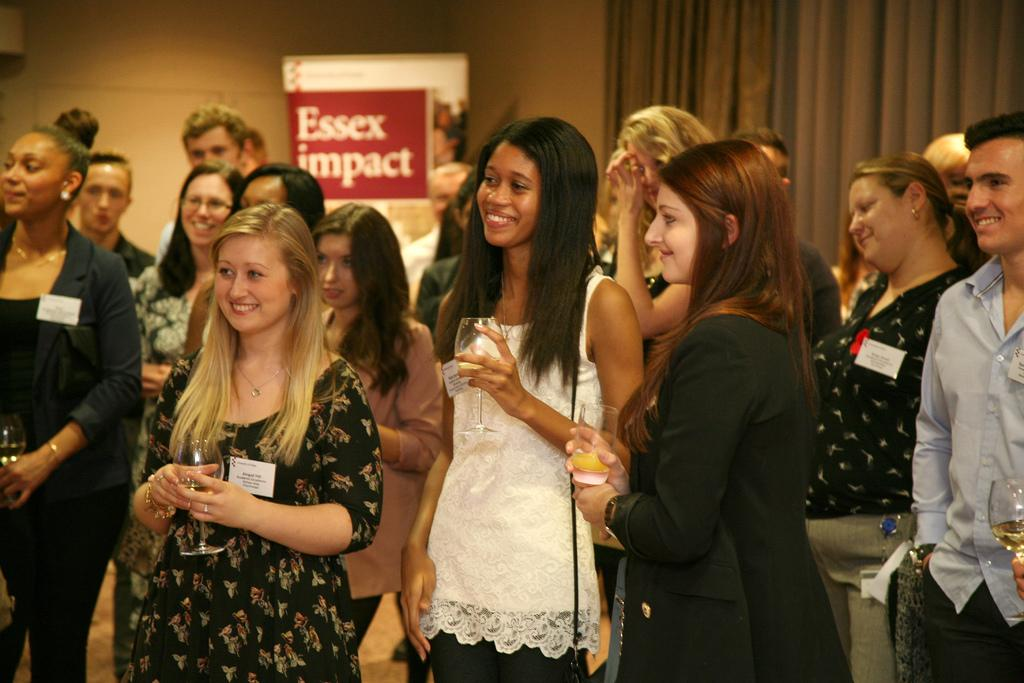How many people are in the image? There are people in the image, but the exact number is not specified. What are some people holding in the image? Some people are holding glasses in the image. What is the general mood or expression of the people in the image? The people in the image are smiling. What can be seen in the background of the image? In the background of the image, there is a curtain, a wall, and a board. Can you tell me how many boys are stretching in the image? There is no information about boys or stretching in the image, so it is not possible to answer this question. 